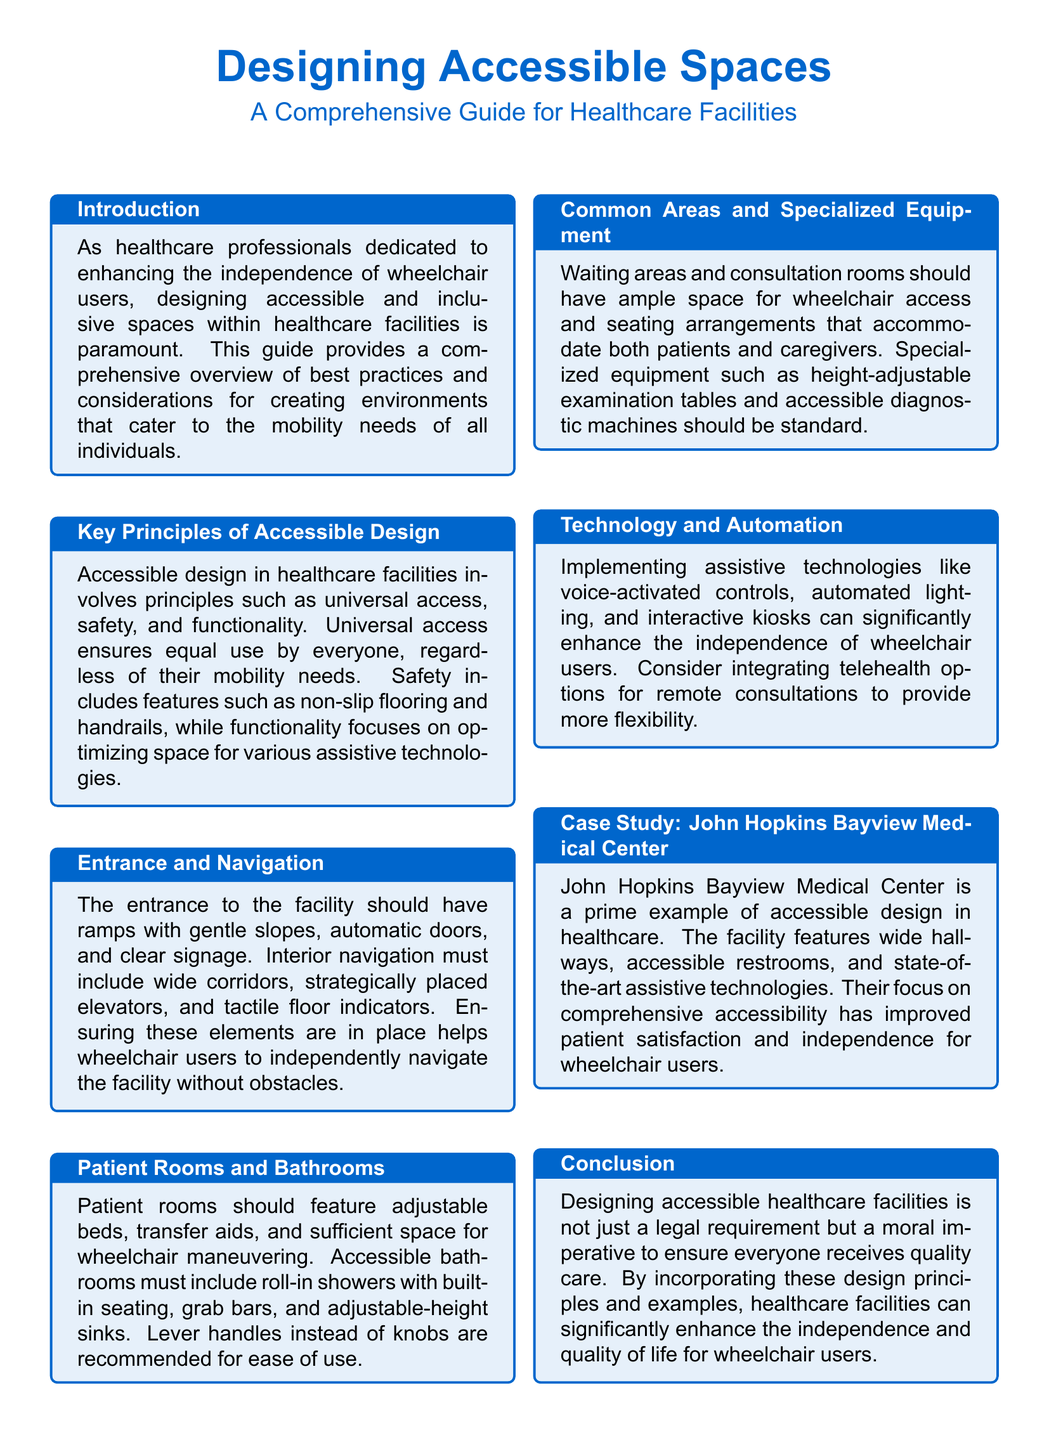What is the title of the guide? The title of the guide is prominently displayed in the document's header.
Answer: Designing Accessible Spaces What is a key principle of accessible design mentioned in the document? The document lists principles of accessible design that can include universal access, safety, and functionality.
Answer: Universal access What specific feature is recommended for patient rooms? The document highlights specific features that should be included in patient rooms to enhance accessibility.
Answer: Adjustable beds What technology is suggested to enhance independence for wheelchair users? The document discusses specific technologies that can aid wheelchair users.
Answer: Voice-activated controls What case study is presented in the document? The document provides a real-world example of accessible design through a case study, mentioned in one of the sections.
Answer: John Hopkins Bayview Medical Center What is a requirement for the entrance of a healthcare facility? The document specifies certain design requirements for the entrance accessibility.
Answer: Ramps with gentle slopes Which area must have enough space for wheelchair access? The document addresses the importance of space for wheelchair users in different areas of the facility.
Answer: Waiting areas What should be included in accessible bathrooms? The document identifies essential features that accessible bathrooms must have to support independent usage.
Answer: Grab bars 